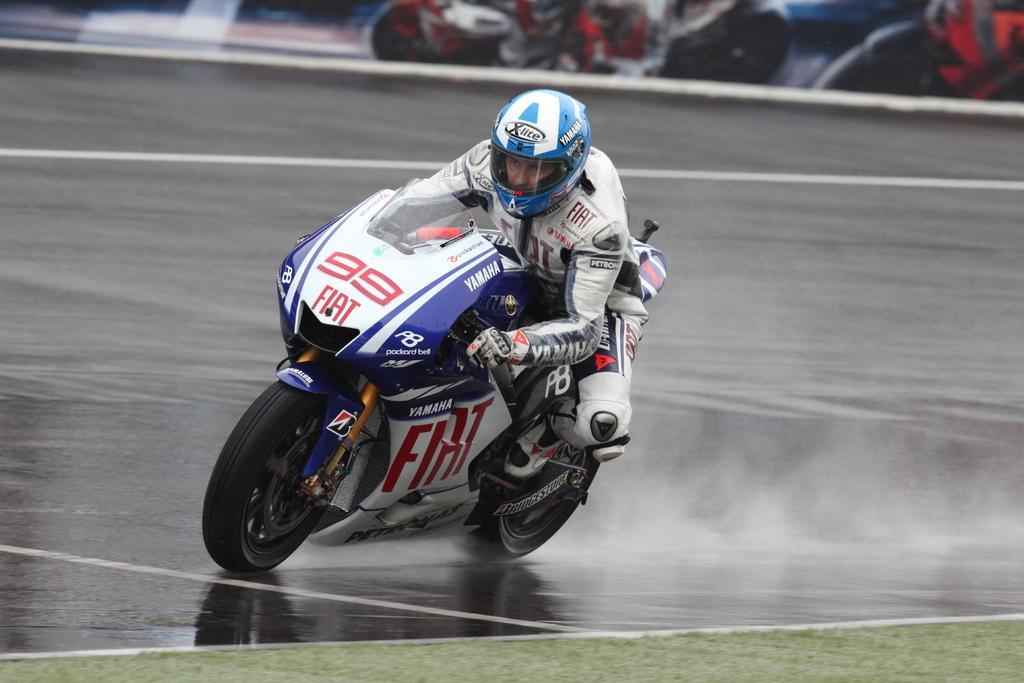What is the person in the image doing? The person is riding a bike in the image. Where is the person riding the bike? The person is on the road. What safety gear is the person wearing? The person is wearing a helmet and gloves. What type of vegetation can be seen in the image? There is grass visible in the image. How would you describe the background of the image? The background of the image is blurry. What is the value of the tomatoes being rubbed by the person in the image? There are no tomatoes present in the image, and the person is not rubbing anything. 